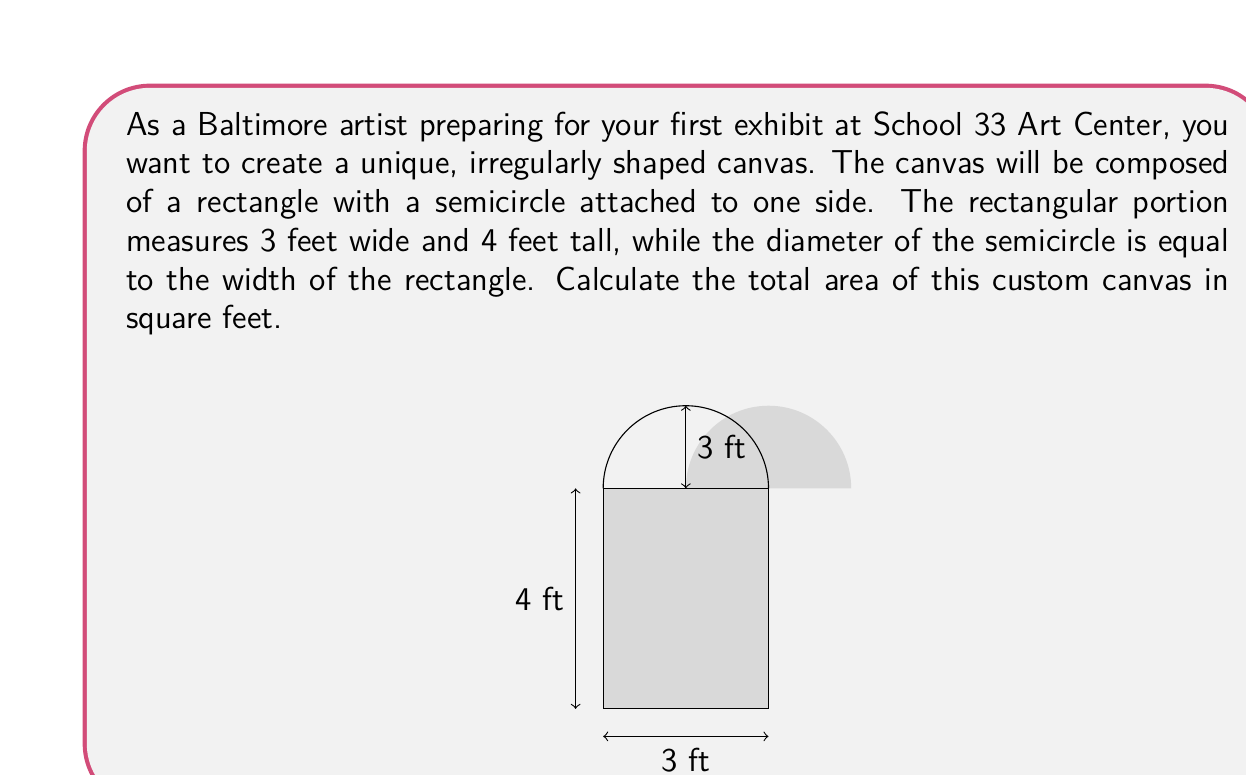Show me your answer to this math problem. To solve this problem, we need to calculate the areas of the rectangular portion and the semicircular portion separately, then add them together.

1. Area of the rectangle:
   $$ A_r = l \times w = 4 \text{ ft} \times 3 \text{ ft} = 12 \text{ sq ft} $$

2. Area of the semicircle:
   The diameter of the semicircle is 3 ft, so the radius is 1.5 ft.
   The formula for the area of a circle is $A = \pi r^2$, and we need half of this for a semicircle.
   $$ A_s = \frac{1}{2} \pi r^2 = \frac{1}{2} \pi (1.5 \text{ ft})^2 = \frac{9\pi}{4} \text{ sq ft} $$

3. Total area:
   $$ A_{\text{total}} = A_r + A_s = 12 \text{ sq ft} + \frac{9\pi}{4} \text{ sq ft} $$

4. Simplifying:
   $$ A_{\text{total}} = 12 + \frac{9\pi}{4} = \frac{48}{4} + \frac{9\pi}{4} = \frac{48 + 9\pi}{4} \text{ sq ft} $$
Answer: $$ \frac{48 + 9\pi}{4} \text{ sq ft} \approx 19.06 \text{ sq ft} $$ 